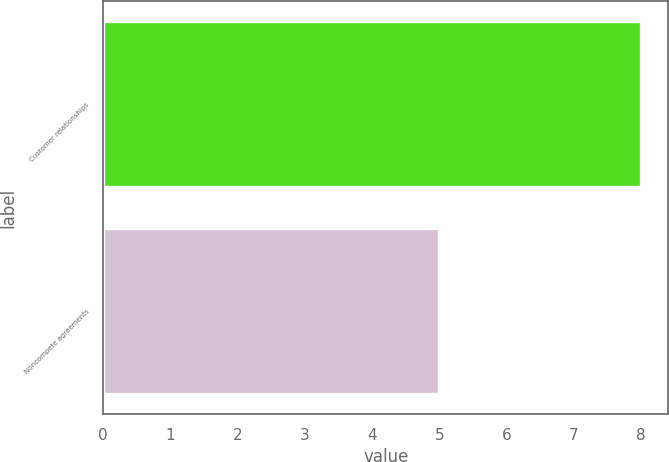Convert chart to OTSL. <chart><loc_0><loc_0><loc_500><loc_500><bar_chart><fcel>Customer relationships<fcel>Noncompete agreements<nl><fcel>8<fcel>5<nl></chart> 